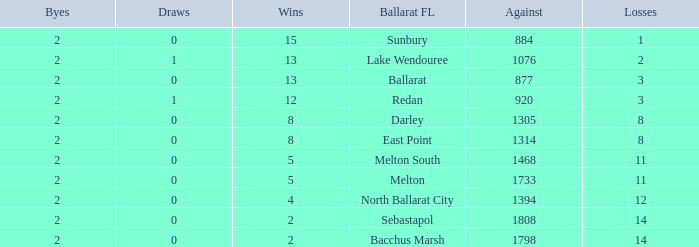Could you parse the entire table? {'header': ['Byes', 'Draws', 'Wins', 'Ballarat FL', 'Against', 'Losses'], 'rows': [['2', '0', '15', 'Sunbury', '884', '1'], ['2', '1', '13', 'Lake Wendouree', '1076', '2'], ['2', '0', '13', 'Ballarat', '877', '3'], ['2', '1', '12', 'Redan', '920', '3'], ['2', '0', '8', 'Darley', '1305', '8'], ['2', '0', '8', 'East Point', '1314', '8'], ['2', '0', '5', 'Melton South', '1468', '11'], ['2', '0', '5', 'Melton', '1733', '11'], ['2', '0', '4', 'North Ballarat City', '1394', '12'], ['2', '0', '2', 'Sebastapol', '1808', '14'], ['2', '0', '2', 'Bacchus Marsh', '1798', '14']]} How many Against has a Ballarat FL of darley and Wins larger than 8? 0.0. 